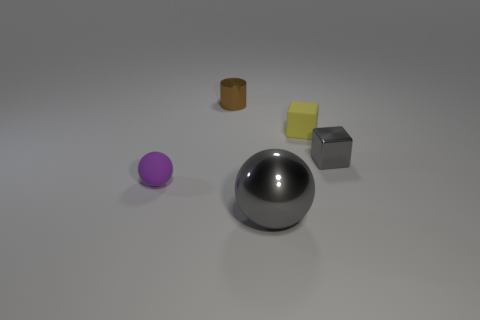Does the yellow block have the same material as the cylinder?
Provide a succinct answer. No. What color is the thing that is in front of the small gray cube and behind the large gray metal ball?
Offer a terse response. Purple. Does the tiny cube behind the small gray metal block have the same color as the cylinder?
Ensure brevity in your answer.  No. There is a yellow thing that is the same size as the purple sphere; what is its shape?
Ensure brevity in your answer.  Cube. What number of other things are there of the same color as the cylinder?
Ensure brevity in your answer.  0. How many other things are the same material as the brown object?
Provide a succinct answer. 2. There is a gray metallic cube; is it the same size as the gray metallic object left of the yellow matte block?
Offer a very short reply. No. What is the color of the large sphere?
Your answer should be very brief. Gray. What is the shape of the object that is in front of the tiny object in front of the gray metallic cube to the right of the tiny brown cylinder?
Make the answer very short. Sphere. What is the material of the small cube that is in front of the tiny yellow thing right of the tiny brown metallic object?
Offer a terse response. Metal. 